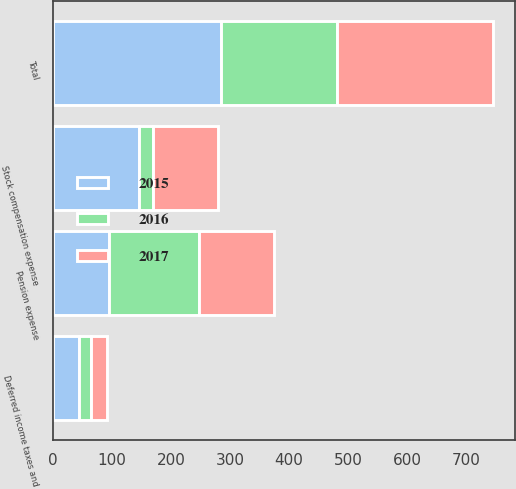Convert chart to OTSL. <chart><loc_0><loc_0><loc_500><loc_500><stacked_bar_chart><ecel><fcel>Pension expense<fcel>Stock compensation expense<fcel>Deferred income taxes and<fcel>Total<nl><fcel>2016<fcel>153<fcel>24<fcel>19<fcel>196<nl><fcel>2015<fcel>95<fcel>145<fcel>45<fcel>285<nl><fcel>2017<fcel>127<fcel>110<fcel>27<fcel>264<nl></chart> 